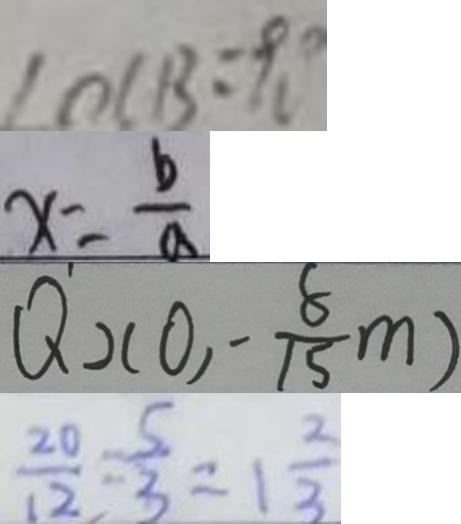<formula> <loc_0><loc_0><loc_500><loc_500>\angle O C B = 9 0 ^ { \circ } 
 x = \frac { b } { a } 
 Q _ { 2 } ( 0 , - \frac { 8 } { 1 5 } m ) 
 \frac { 2 0 } { 1 2 } = \frac { 5 } { 3 } = 1 \frac { 2 } { 3 }</formula> 